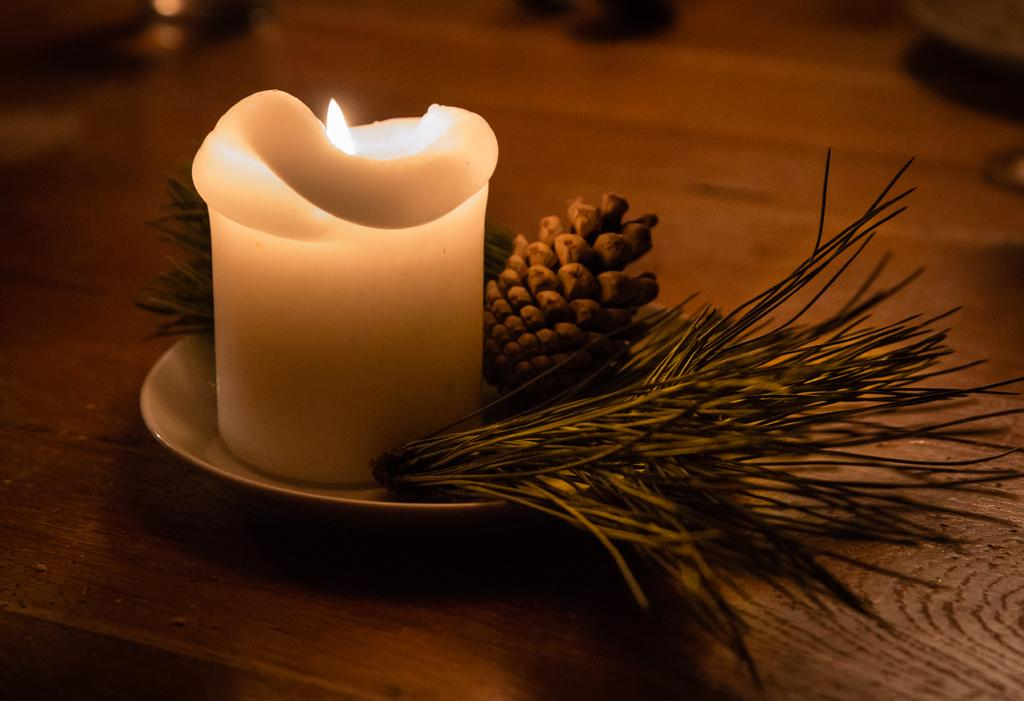What is on the plate that is visible in the image? There is a candle on the plate in the image. What type of natural environment is depicted in the image? There is grass in the image, suggesting a natural setting. What is the object on the wooden platform in the image? The facts do not specify the object on the wooden platform, so we cannot answer this question definitively. How would you describe the background of the image? The background of the image is blurry. What angle is the statement made at in the image? There is no statement present in the image, so we cannot determine the angle at which it might be made. How hot is the candle in the image? The facts do not provide information about the temperature of the candle, so we cannot answer this question definitively. 